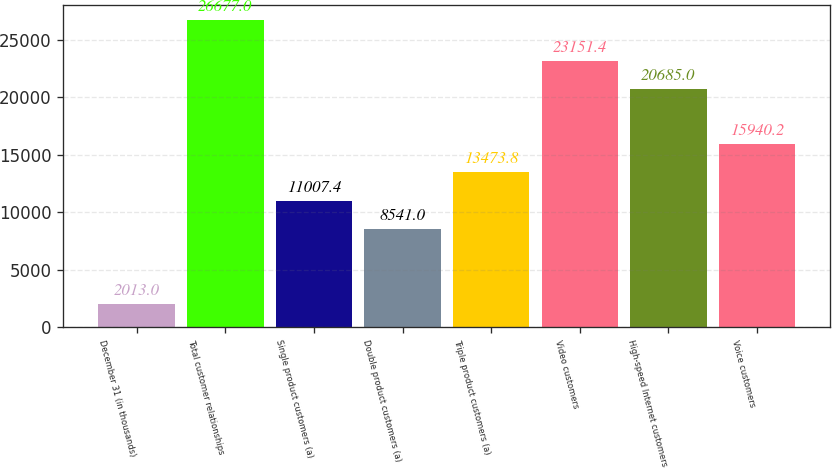<chart> <loc_0><loc_0><loc_500><loc_500><bar_chart><fcel>December 31 (in thousands)<fcel>Total customer relationships<fcel>Single product customers (a)<fcel>Double product customers (a)<fcel>Triple product customers (a)<fcel>Video customers<fcel>High-speed Internet customers<fcel>Voice customers<nl><fcel>2013<fcel>26677<fcel>11007.4<fcel>8541<fcel>13473.8<fcel>23151.4<fcel>20685<fcel>15940.2<nl></chart> 